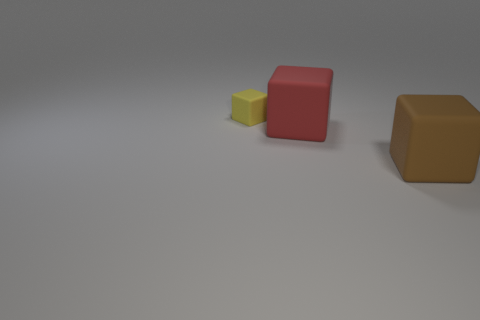Add 1 small gray cubes. How many objects exist? 4 Subtract all purple balls. Subtract all small yellow matte things. How many objects are left? 2 Add 3 large matte objects. How many large matte objects are left? 5 Add 1 big purple matte balls. How many big purple matte balls exist? 1 Subtract 0 cyan blocks. How many objects are left? 3 